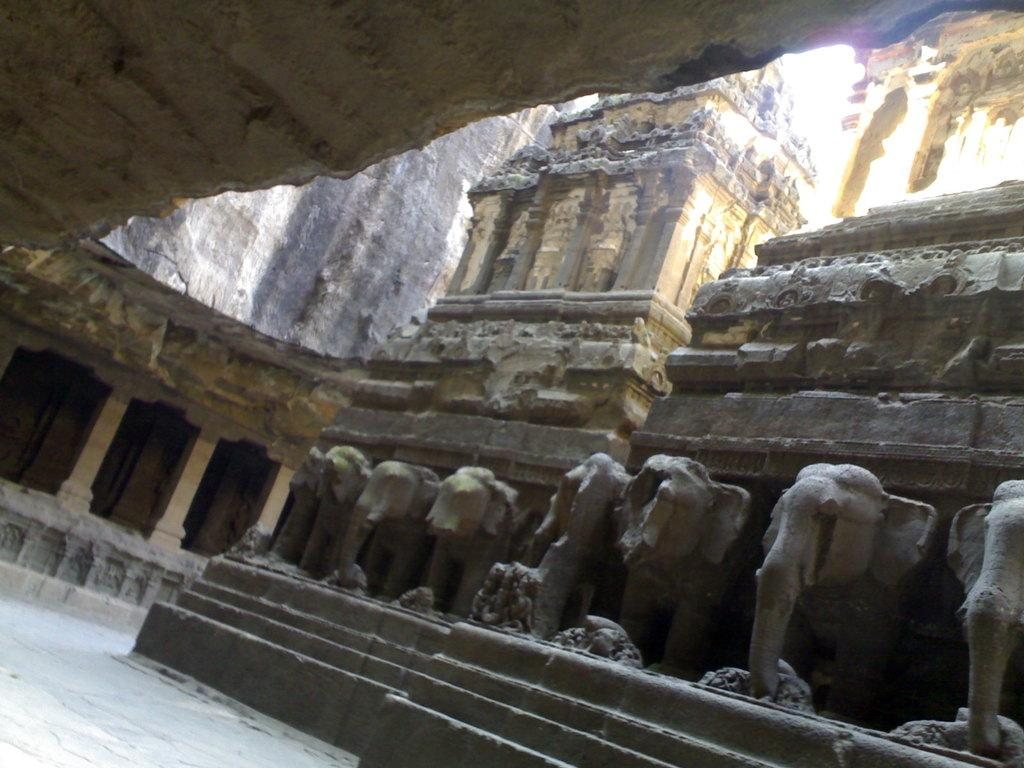What type of sculptures are present in the image? There are elephant sculptures in the image. Where are the elephant sculptures located in the image? The elephant sculptures are in the front of the image. What can be seen in the background of the image? There is an inside view of a building in the background of the image. Is there a minister involved in a fight with the elephant sculptures in the image? There is no minister or fight present in the image; it only features elephant sculptures and an inside view of a building. 